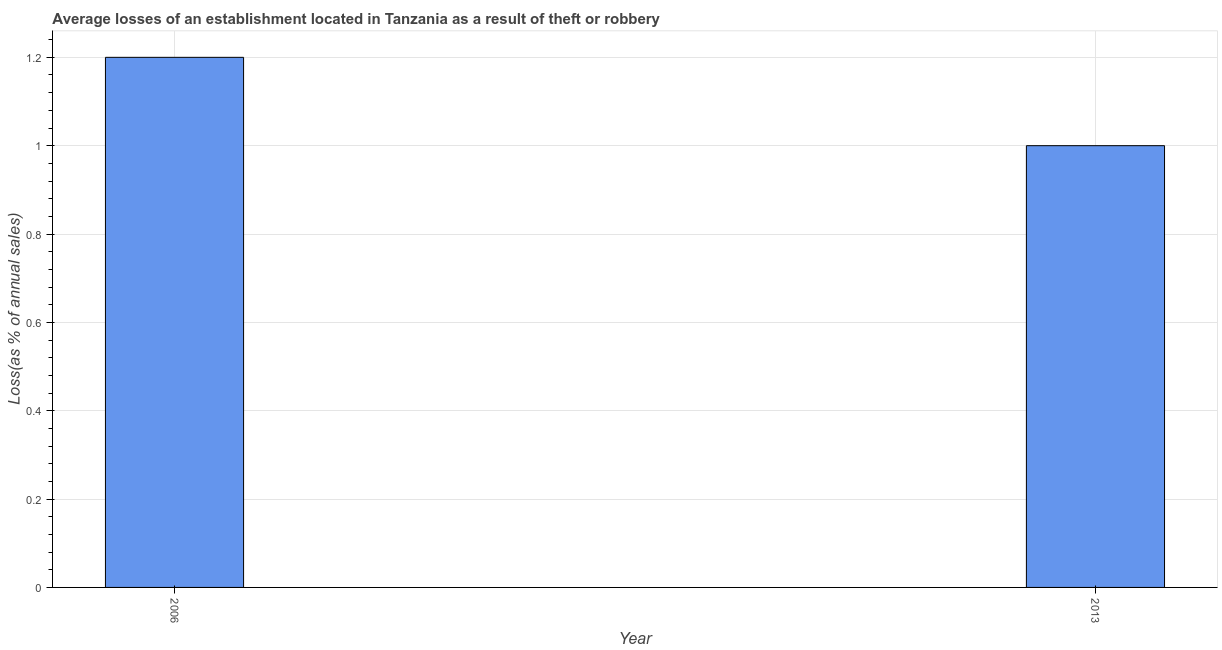Does the graph contain any zero values?
Offer a terse response. No. What is the title of the graph?
Keep it short and to the point. Average losses of an establishment located in Tanzania as a result of theft or robbery. What is the label or title of the Y-axis?
Ensure brevity in your answer.  Loss(as % of annual sales). What is the losses due to theft in 2013?
Your answer should be very brief. 1. What is the median losses due to theft?
Offer a terse response. 1.1. Do a majority of the years between 2006 and 2013 (inclusive) have losses due to theft greater than 1.2 %?
Your answer should be very brief. No. How many bars are there?
Offer a very short reply. 2. Are the values on the major ticks of Y-axis written in scientific E-notation?
Give a very brief answer. No. What is the Loss(as % of annual sales) in 2013?
Ensure brevity in your answer.  1. 